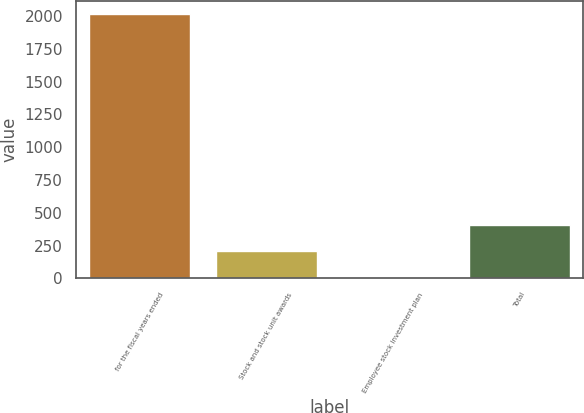Convert chart. <chart><loc_0><loc_0><loc_500><loc_500><bar_chart><fcel>for the fiscal years ended<fcel>Stock and stock unit awards<fcel>Employee stock investment plan<fcel>Total<nl><fcel>2017<fcel>207.46<fcel>6.4<fcel>408.52<nl></chart> 